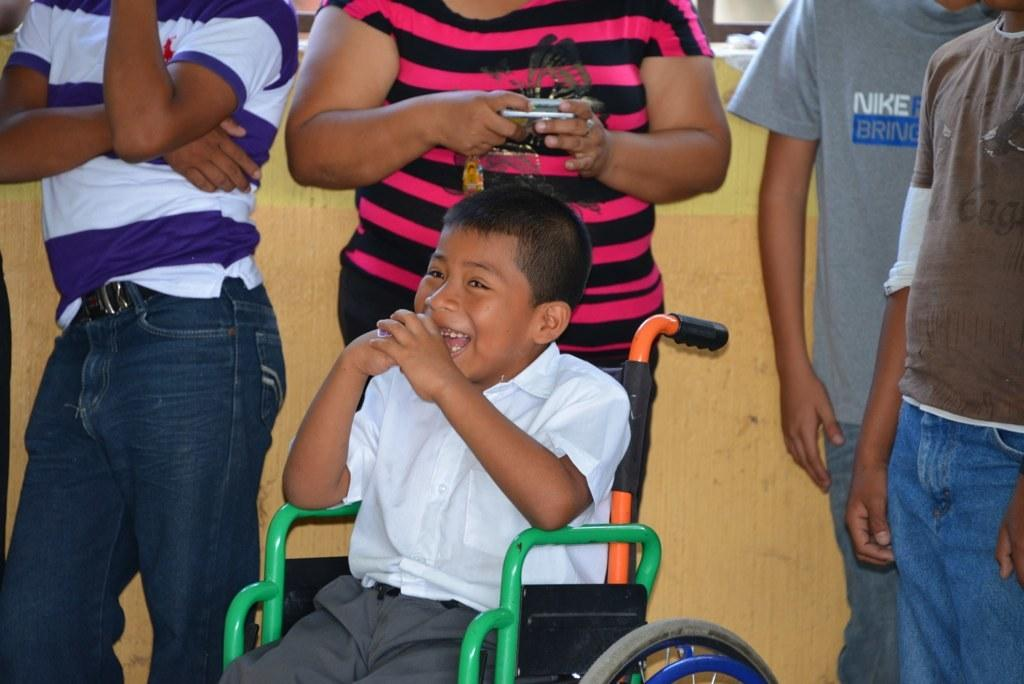Who is the main subject in the image? There is a boy in the image. What is the boy's position in the image? The boy is sitting in a wheelchair. What is the boy wearing in the image? The boy is wearing a white shirt and gray pants. What can be seen in the background of the image? There are people standing in the background of the image, and there is a wall. What type of event is the boy attending in the image? There is no indication of an event in the image; it simply shows the boy sitting in a wheelchair. How many chairs are visible in the image? There is no mention of chairs in the image; the boy is sitting in a wheelchair. 